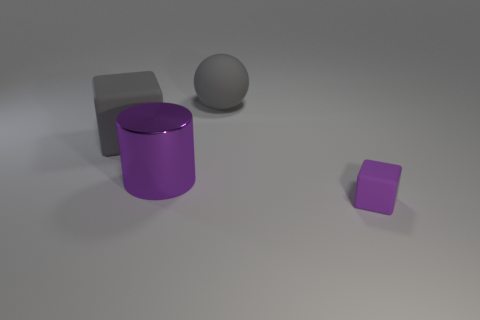The thing that is the same color as the large block is what size?
Provide a succinct answer. Large. What is the material of the small block that is the same color as the large metallic thing?
Your answer should be very brief. Rubber. What number of large gray things are the same shape as the small thing?
Ensure brevity in your answer.  1. Is the number of large gray matte objects that are to the left of the big gray sphere greater than the number of large purple things?
Make the answer very short. No. What shape is the rubber thing on the left side of the large rubber ball that is to the right of the large object in front of the gray matte block?
Keep it short and to the point. Cube. Does the rubber object that is left of the big purple cylinder have the same shape as the purple object behind the purple cube?
Your answer should be compact. No. Is there anything else that is the same size as the gray matte block?
Offer a very short reply. Yes. What number of blocks are either small purple rubber objects or large purple rubber objects?
Ensure brevity in your answer.  1. Is the material of the sphere the same as the tiny cube?
Provide a short and direct response. Yes. What number of other objects are the same color as the metal cylinder?
Keep it short and to the point. 1. 